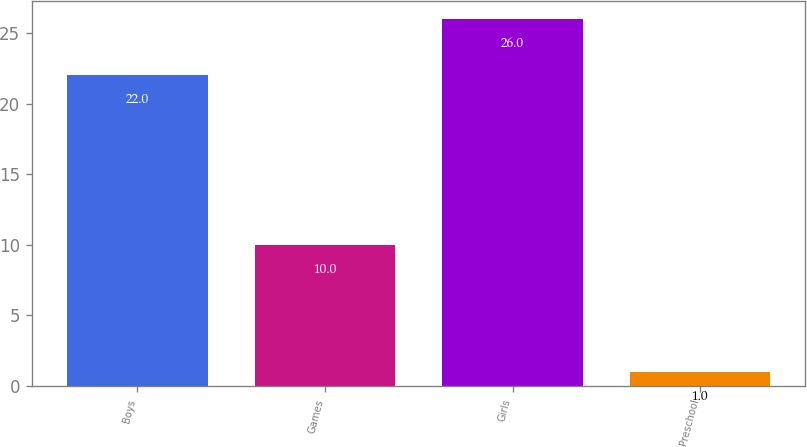Convert chart to OTSL. <chart><loc_0><loc_0><loc_500><loc_500><bar_chart><fcel>Boys<fcel>Games<fcel>Girls<fcel>Preschool<nl><fcel>22<fcel>10<fcel>26<fcel>1<nl></chart> 